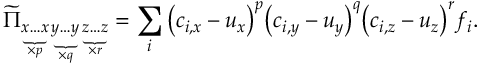<formula> <loc_0><loc_0><loc_500><loc_500>\widetilde { \Pi } _ { \underbrace { x \dots x } _ { \times p } \underbrace { y \dots y } _ { \times q } \underbrace { z \dots z } _ { \times r } } = \sum _ { i } { \left ( c _ { i , x } - u _ { x } \right ) } ^ { p } { \left ( c _ { i , y } - u _ { y } \right ) } ^ { q } { \left ( c _ { i , z } - u _ { z } \right ) } ^ { r } f _ { i } .</formula> 